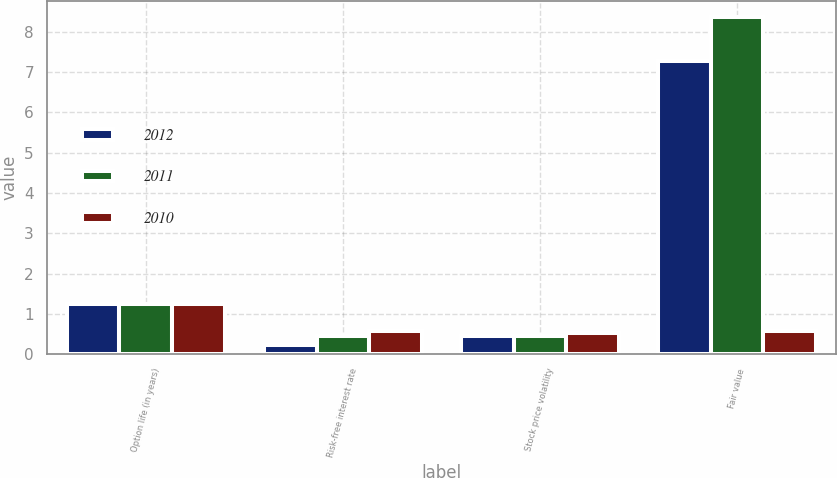Convert chart to OTSL. <chart><loc_0><loc_0><loc_500><loc_500><stacked_bar_chart><ecel><fcel>Option life (in years)<fcel>Risk-free interest rate<fcel>Stock price volatility<fcel>Fair value<nl><fcel>2012<fcel>1.24<fcel>0.22<fcel>0.46<fcel>7.29<nl><fcel>2011<fcel>1.25<fcel>0.44<fcel>0.44<fcel>8.36<nl><fcel>2010<fcel>1.24<fcel>0.57<fcel>0.53<fcel>0.57<nl></chart> 